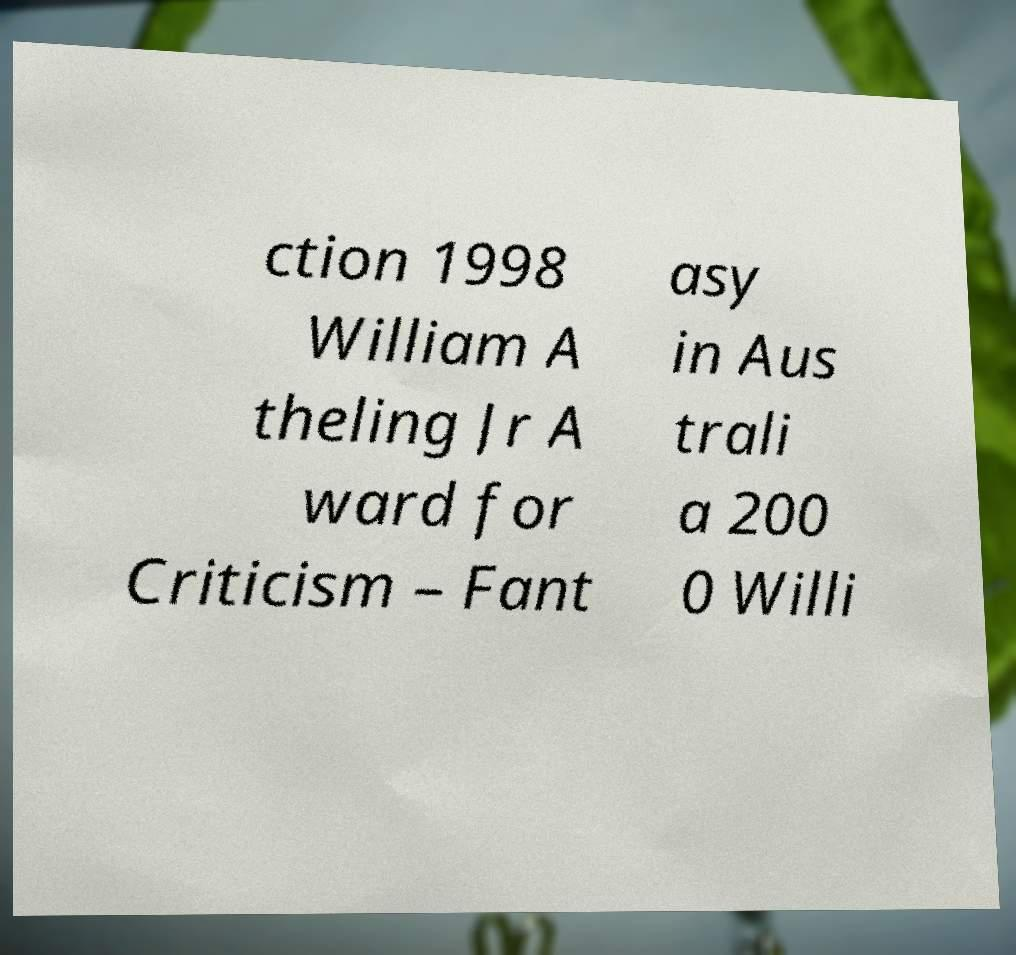Can you read and provide the text displayed in the image?This photo seems to have some interesting text. Can you extract and type it out for me? ction 1998 William A theling Jr A ward for Criticism – Fant asy in Aus trali a 200 0 Willi 